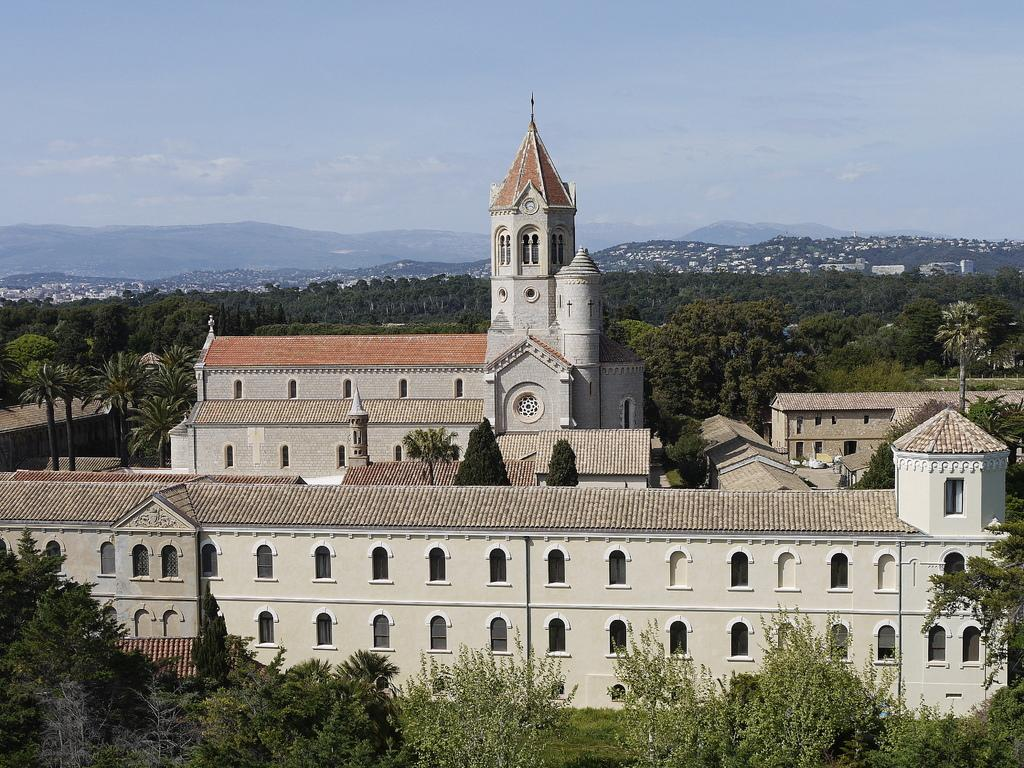What type of vegetation is visible in the front of the image? There are trees in the front of the image. What type of structures are located in the center of the image? There are buildings in the center of the image. What type of vegetation is visible in the background of the image? There are trees in the background of the image. What type of structures are visible in the background of the image? There are buildings in the background of the image. What natural feature can be seen in the background of the image? There are mountains in the background of the image. What is the condition of the sky in the image? The sky is cloudy in the image. How many bags does the laborer carry in the image? There are no bags or laborers present in the image. What emotion is expressed by the trees in the image? Trees do not express emotions; they are inanimate objects. 